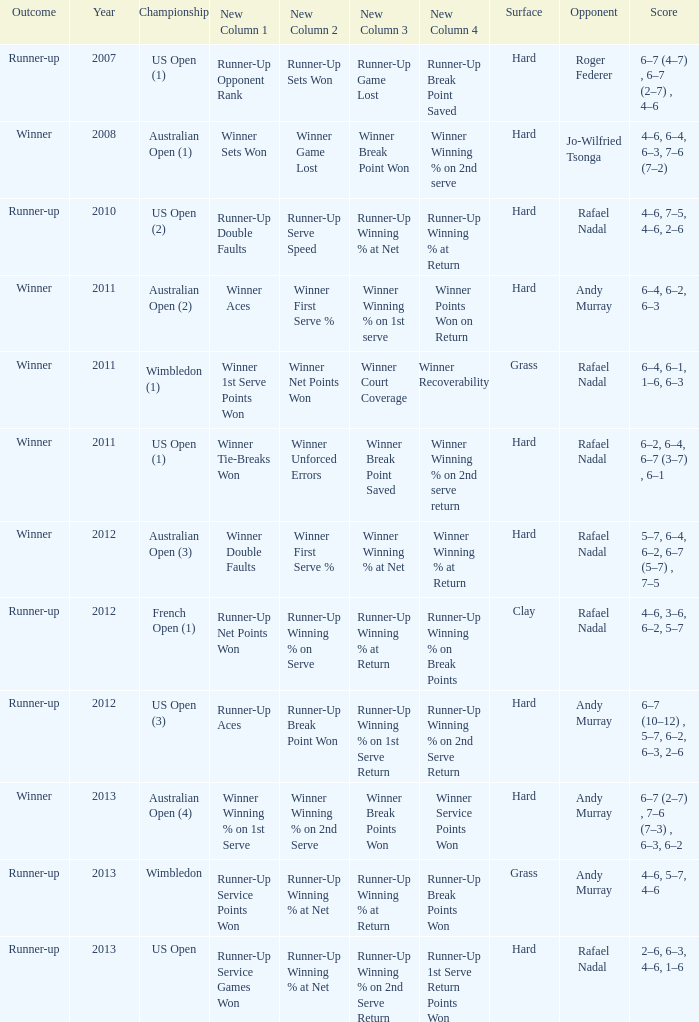What is the outcome of the 4–6, 6–4, 6–3, 7–6 (7–2) score? Winner. 